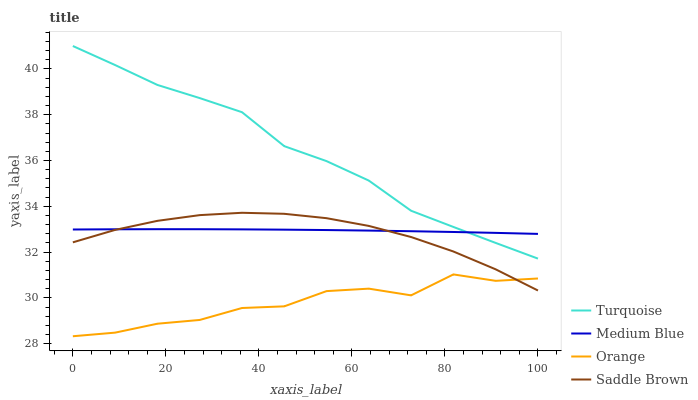Does Orange have the minimum area under the curve?
Answer yes or no. Yes. Does Turquoise have the maximum area under the curve?
Answer yes or no. Yes. Does Medium Blue have the minimum area under the curve?
Answer yes or no. No. Does Medium Blue have the maximum area under the curve?
Answer yes or no. No. Is Medium Blue the smoothest?
Answer yes or no. Yes. Is Orange the roughest?
Answer yes or no. Yes. Is Turquoise the smoothest?
Answer yes or no. No. Is Turquoise the roughest?
Answer yes or no. No. Does Orange have the lowest value?
Answer yes or no. Yes. Does Turquoise have the lowest value?
Answer yes or no. No. Does Turquoise have the highest value?
Answer yes or no. Yes. Does Medium Blue have the highest value?
Answer yes or no. No. Is Orange less than Turquoise?
Answer yes or no. Yes. Is Medium Blue greater than Orange?
Answer yes or no. Yes. Does Saddle Brown intersect Orange?
Answer yes or no. Yes. Is Saddle Brown less than Orange?
Answer yes or no. No. Is Saddle Brown greater than Orange?
Answer yes or no. No. Does Orange intersect Turquoise?
Answer yes or no. No. 